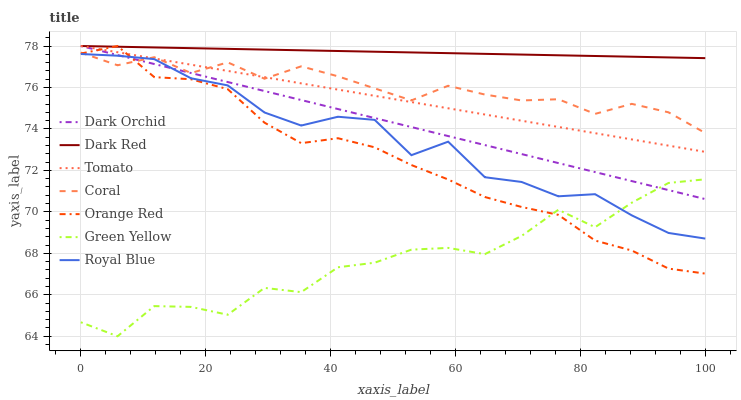Does Green Yellow have the minimum area under the curve?
Answer yes or no. Yes. Does Dark Red have the maximum area under the curve?
Answer yes or no. Yes. Does Coral have the minimum area under the curve?
Answer yes or no. No. Does Coral have the maximum area under the curve?
Answer yes or no. No. Is Tomato the smoothest?
Answer yes or no. Yes. Is Green Yellow the roughest?
Answer yes or no. Yes. Is Dark Red the smoothest?
Answer yes or no. No. Is Dark Red the roughest?
Answer yes or no. No. Does Green Yellow have the lowest value?
Answer yes or no. Yes. Does Coral have the lowest value?
Answer yes or no. No. Does Orange Red have the highest value?
Answer yes or no. Yes. Does Coral have the highest value?
Answer yes or no. No. Is Coral less than Dark Red?
Answer yes or no. Yes. Is Coral greater than Green Yellow?
Answer yes or no. Yes. Does Dark Red intersect Tomato?
Answer yes or no. Yes. Is Dark Red less than Tomato?
Answer yes or no. No. Is Dark Red greater than Tomato?
Answer yes or no. No. Does Coral intersect Dark Red?
Answer yes or no. No. 